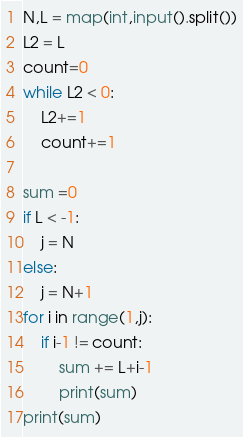Convert code to text. <code><loc_0><loc_0><loc_500><loc_500><_Python_>
N,L = map(int,input().split())
L2 = L
count=0
while L2 < 0:
    L2+=1
    count+=1

sum =0
if L < -1:
    j = N
else:
    j = N+1
for i in range(1,j):
    if i-1 != count:
        sum += L+i-1
        print(sum)
print(sum)</code> 